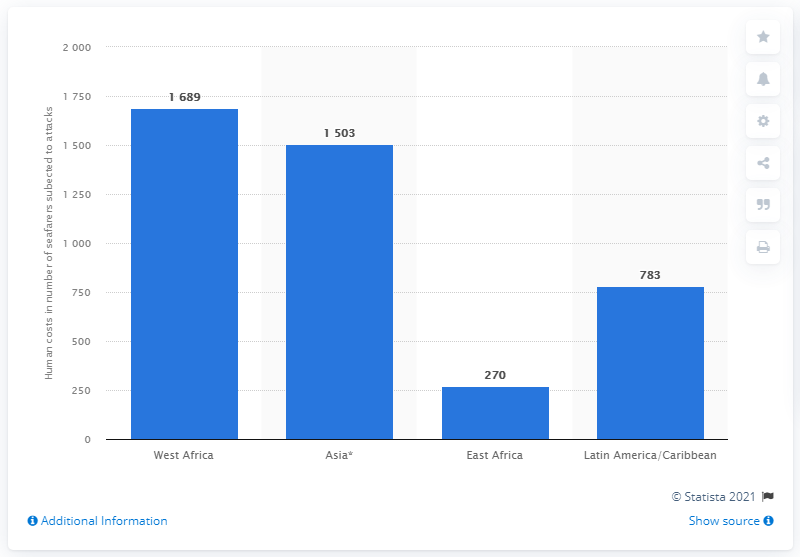Outline some significant characteristics in this image. The difference in attacks between West Africa and Asia is significant, with West Africa experiencing a higher number of cases. East Africa has the least number of attacks compared to other countries. 